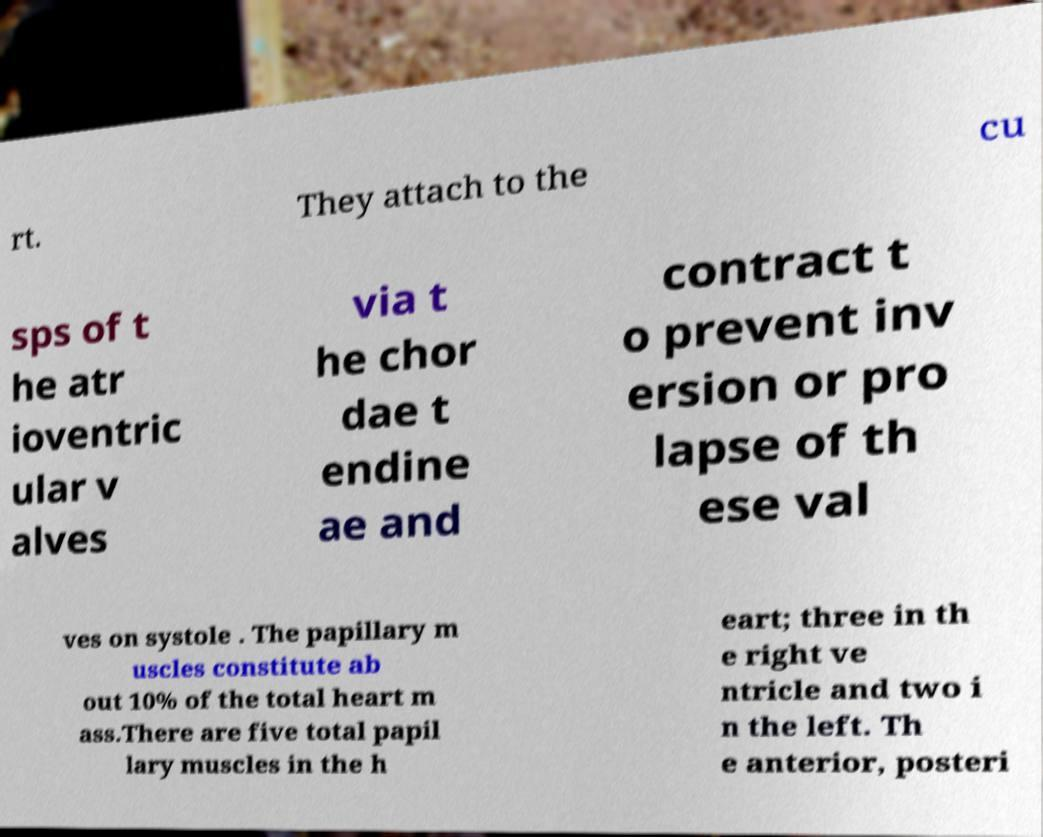Could you assist in decoding the text presented in this image and type it out clearly? rt. They attach to the cu sps of t he atr ioventric ular v alves via t he chor dae t endine ae and contract t o prevent inv ersion or pro lapse of th ese val ves on systole . The papillary m uscles constitute ab out 10% of the total heart m ass.There are five total papil lary muscles in the h eart; three in th e right ve ntricle and two i n the left. Th e anterior, posteri 